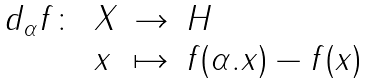<formula> <loc_0><loc_0><loc_500><loc_500>\begin{array} { l l l l } d _ { \alpha } f \colon & X & \rightarrow & H \\ & x & \mapsto & f ( \alpha . x ) - f ( x ) \end{array}</formula> 